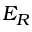<formula> <loc_0><loc_0><loc_500><loc_500>E _ { R }</formula> 